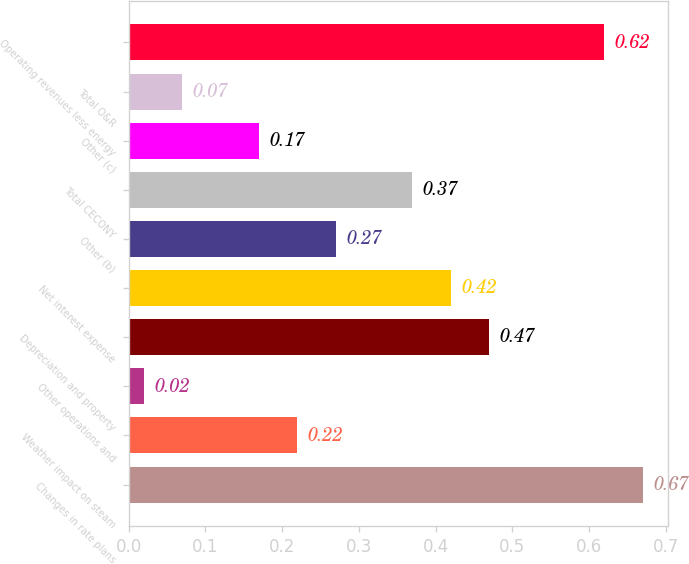<chart> <loc_0><loc_0><loc_500><loc_500><bar_chart><fcel>Changes in rate plans<fcel>Weather impact on steam<fcel>Other operations and<fcel>Depreciation and property<fcel>Net interest expense<fcel>Other (b)<fcel>Total CECONY<fcel>Other (c)<fcel>Total O&R<fcel>Operating revenues less energy<nl><fcel>0.67<fcel>0.22<fcel>0.02<fcel>0.47<fcel>0.42<fcel>0.27<fcel>0.37<fcel>0.17<fcel>0.07<fcel>0.62<nl></chart> 